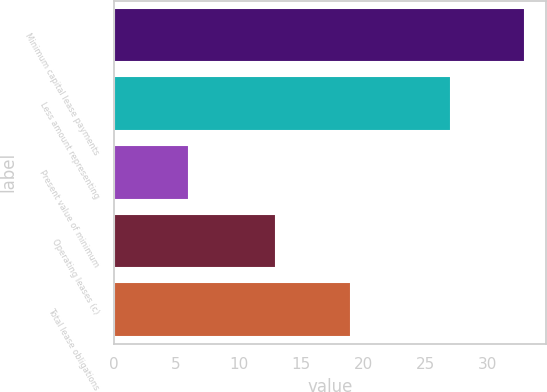Convert chart. <chart><loc_0><loc_0><loc_500><loc_500><bar_chart><fcel>Minimum capital lease payments<fcel>Less amount representing<fcel>Present value of minimum<fcel>Operating leases (c)<fcel>Total lease obligations<nl><fcel>33<fcel>27<fcel>6<fcel>13<fcel>19<nl></chart> 